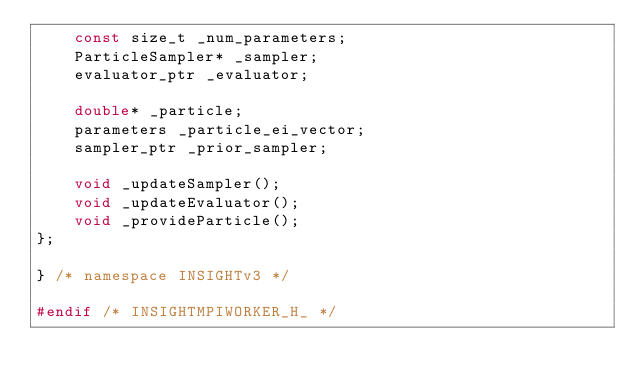<code> <loc_0><loc_0><loc_500><loc_500><_C_>	const size_t _num_parameters;
	ParticleSampler* _sampler;
	evaluator_ptr _evaluator;

	double* _particle;
	parameters _particle_ei_vector;
	sampler_ptr _prior_sampler;

	void _updateSampler();
	void _updateEvaluator();
	void _provideParticle();
};

} /* namespace INSIGHTv3 */

#endif /* INSIGHTMPIWORKER_H_ */
</code> 